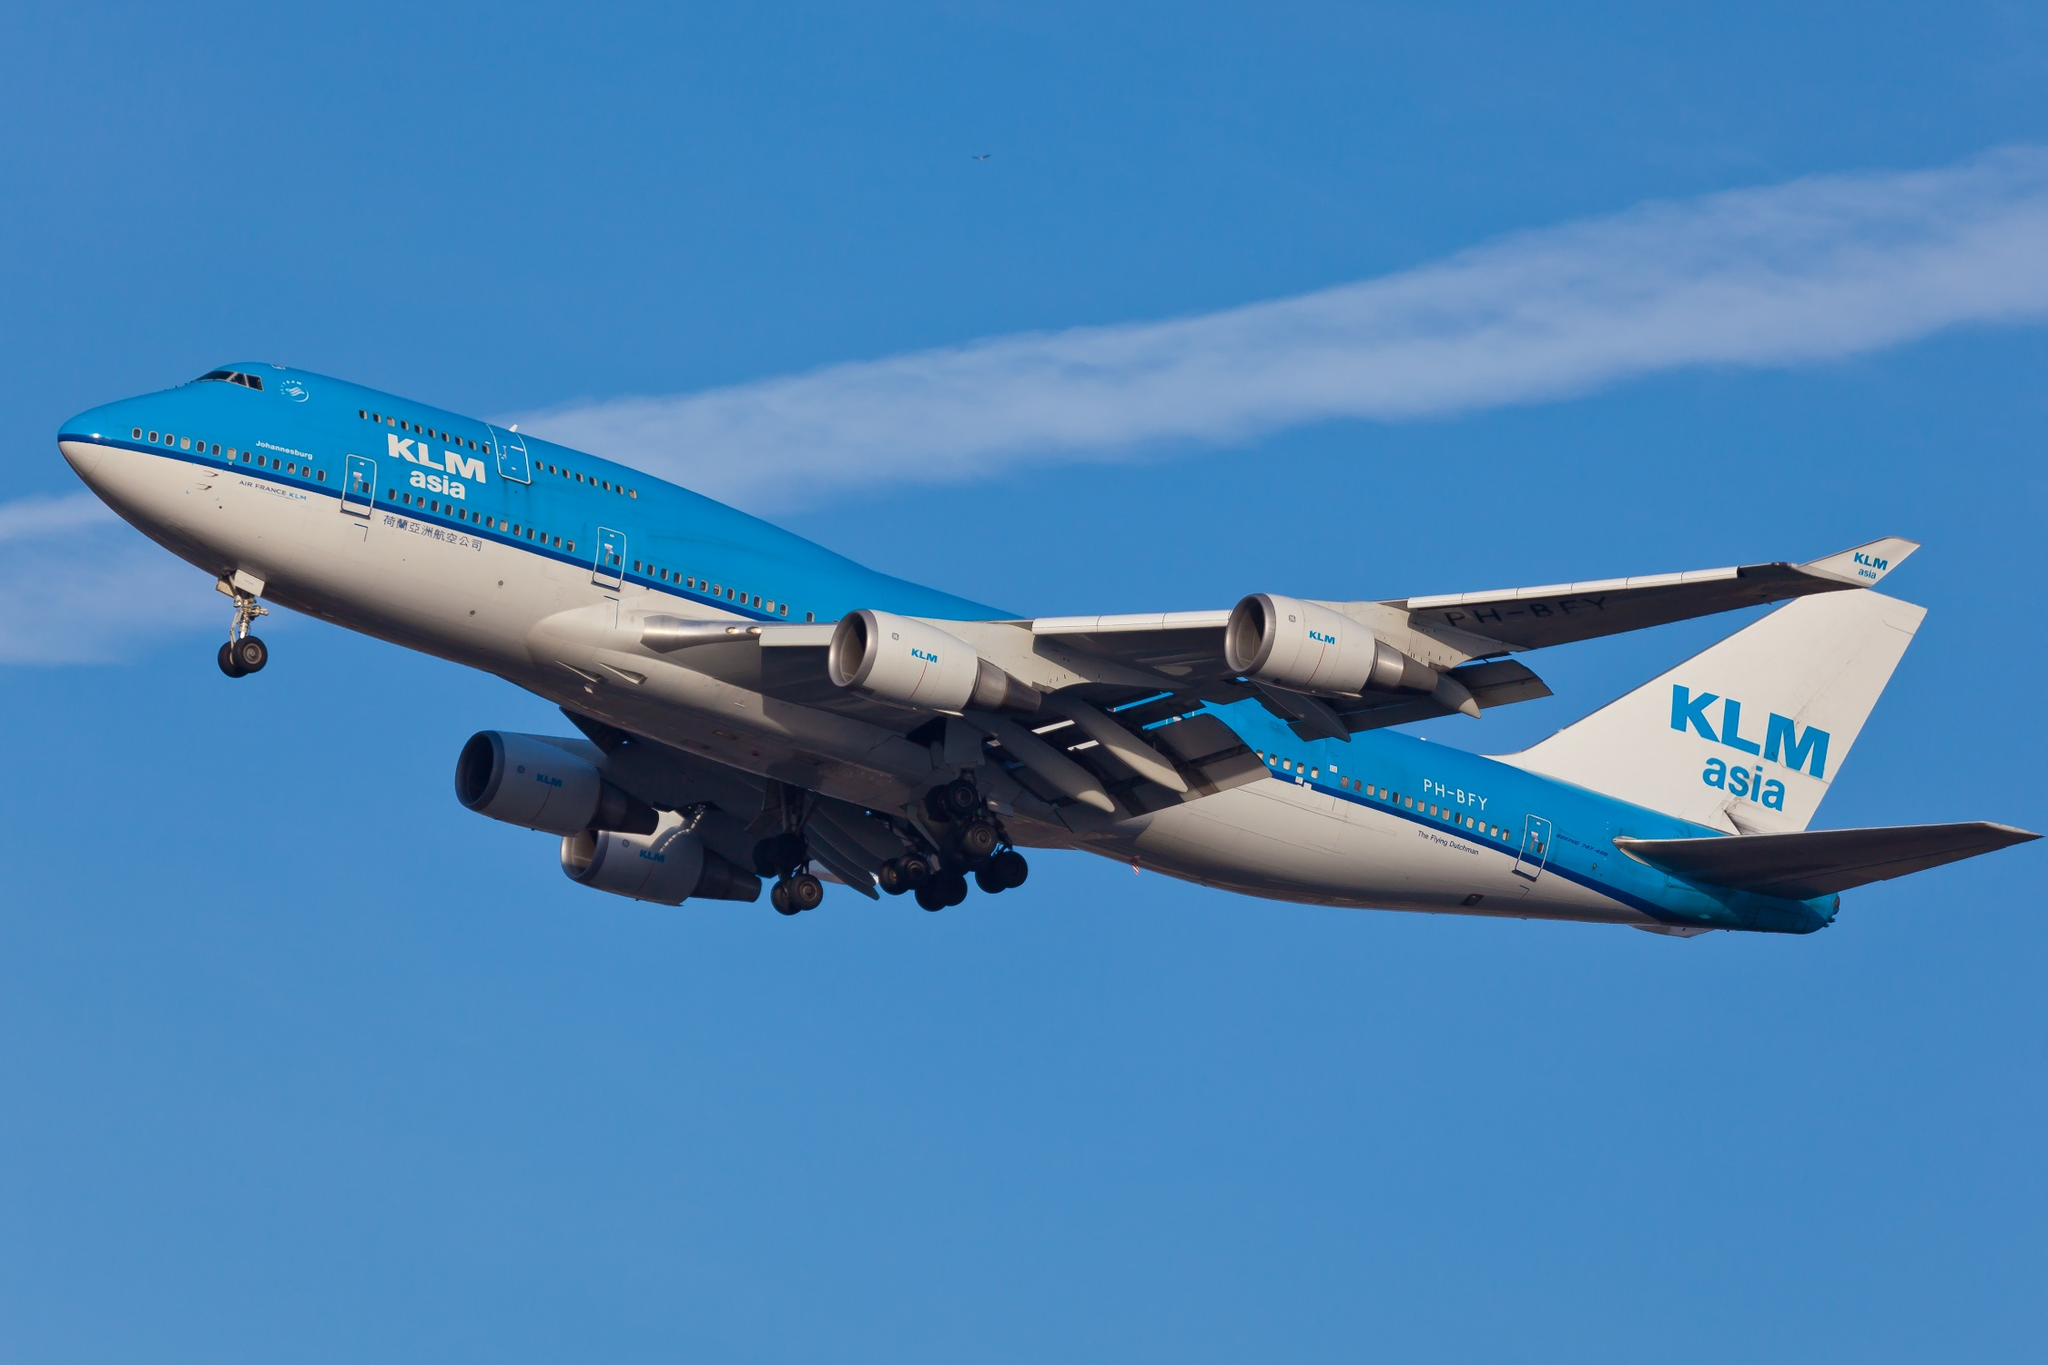What are the key elements in this picture? The image showcases a KLM Asia Boeing 747-400 aircraft majestically soaring through the clear blue sky. The aircraft, painted in a striking blue and white color scheme, displays "KLM Asia" proudly on its tail. Captured from a side angle, the nose of the aircraft is pointed towards the top left corner of the image, giving a sense of direction and movement. The vast expanse of the clear blue sky forms a serene backdrop, emphasizing the solitary journey of the aircraft. The image encapsulates the marvel of modern aviation technology and the freedom of flight. 